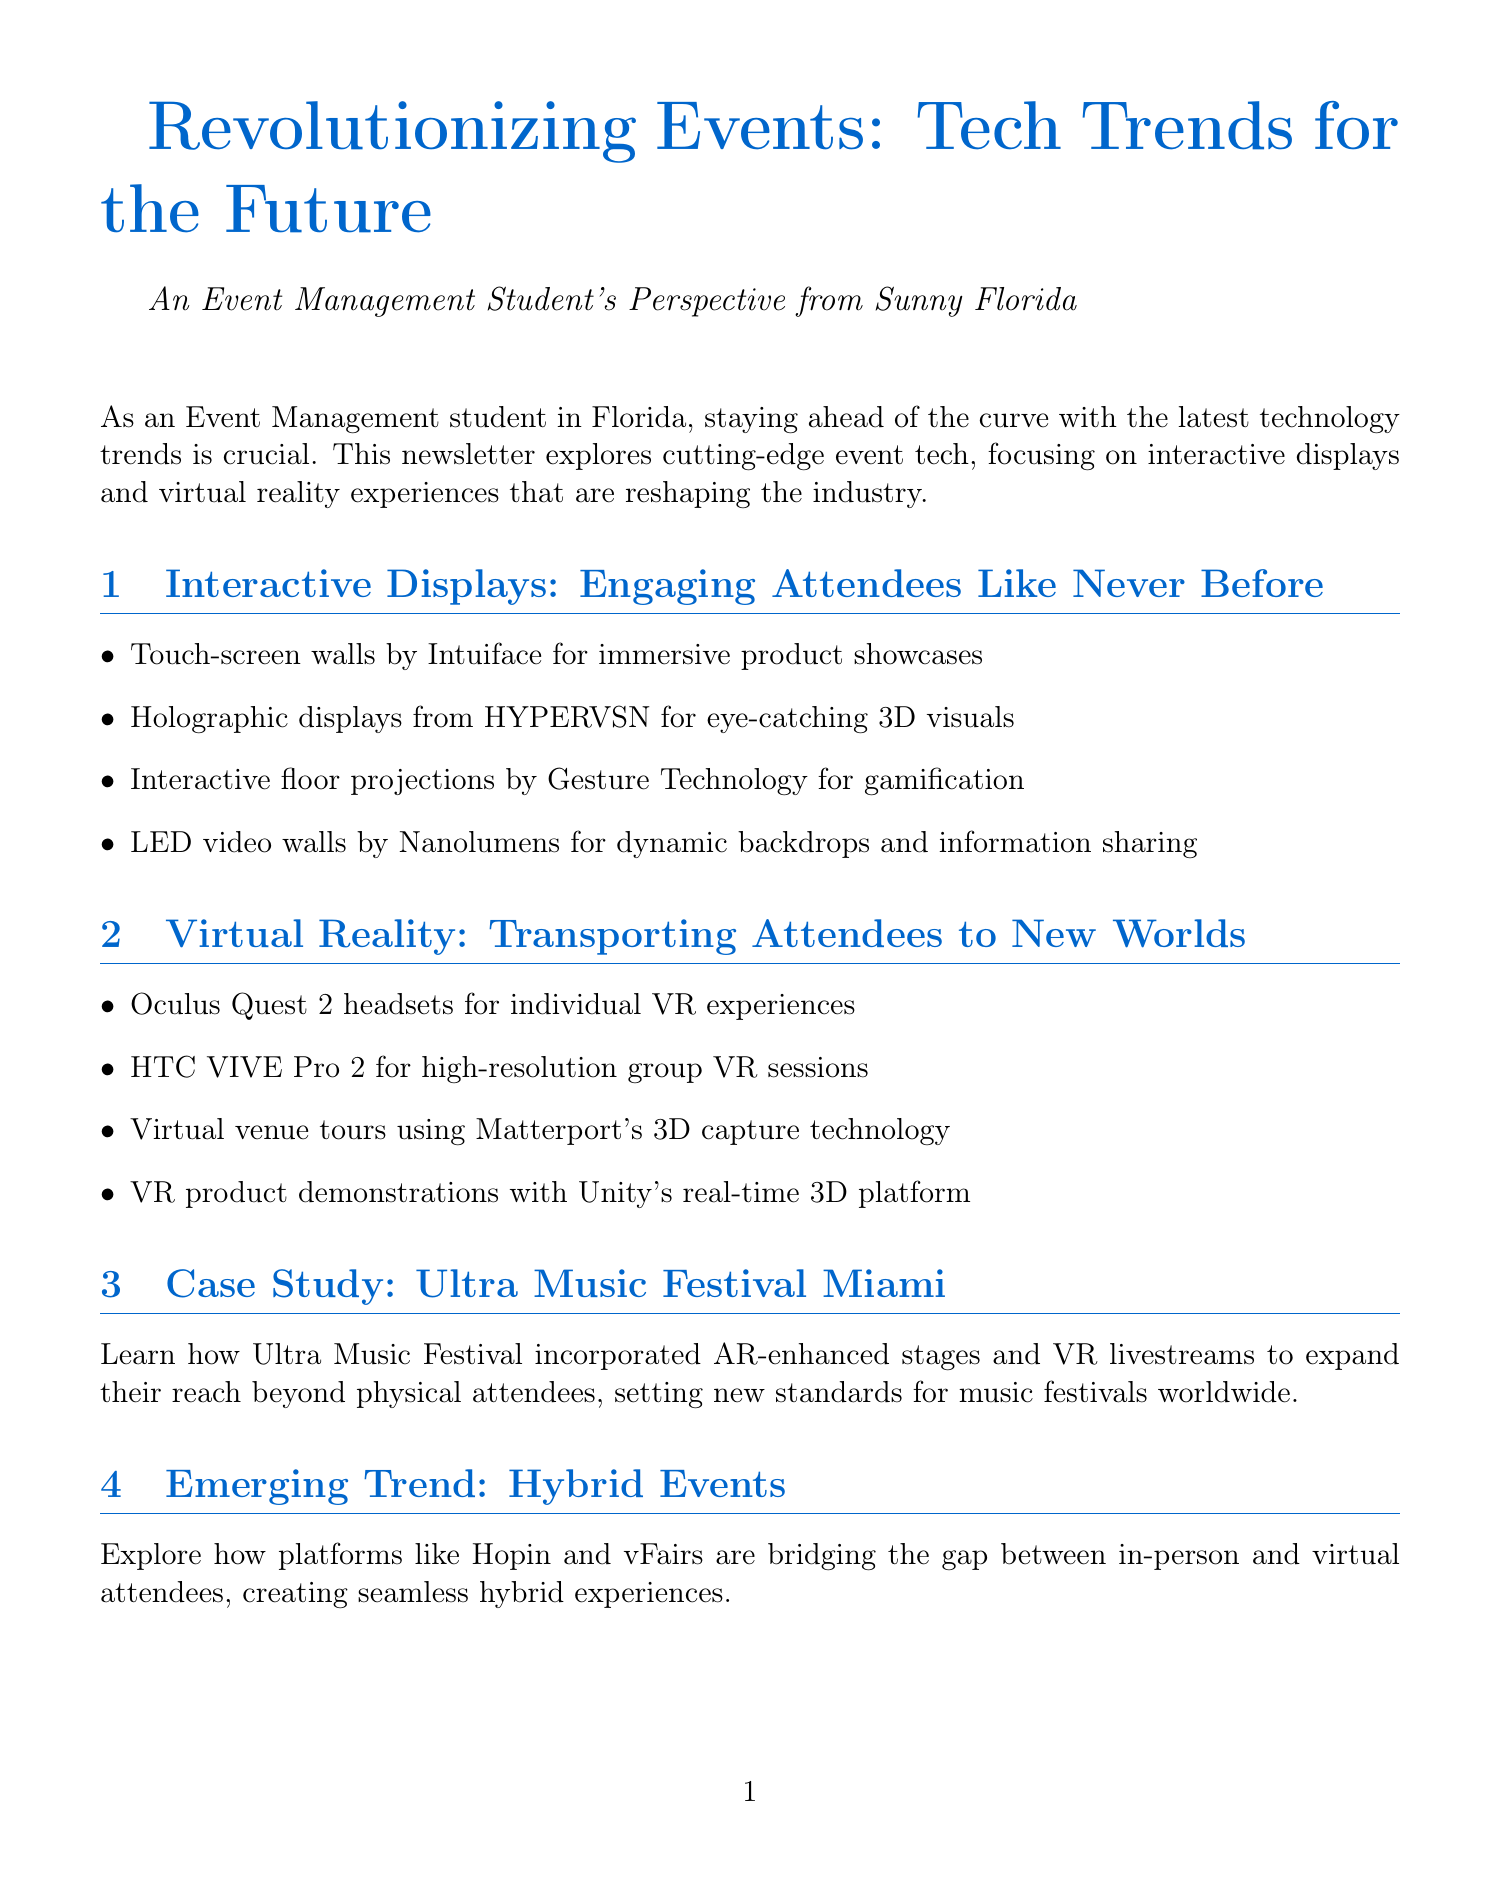What is the newsletter title? The title is prominently stated at the beginning of the document.
Answer: Revolutionizing Events: Tech Trends for the Future Who is interviewed in the newsletter? The document mentions an interview with a specific individual regarding event technology.
Answer: Sarah Johnson What technology is highlighted for immersive product showcases? The content lists various technologies, including one specifically for product showcases.
Answer: Touch-screen walls by Intuiface What event is used as a case study? The document includes a specific music festival as a case study for new technologies.
Answer: Ultra Music Festival Miami What is the name of the program that incorporates event technology? A program at a specific university is mentioned for providing hands-on experience with event tech.
Answer: Florida International University What type of displays are mentioned for gamification? The newsletter lists different technologies, including one specifically for gamification purposes.
Answer: Interactive floor projections by Gesture Technology What platform is mentioned for hybrid events? The content discusses platforms that facilitate hybrid events, specifying one of them.
Answer: Hopin What technology enables virtual venue tours? The document specifies a technology that allows for virtual tours of venues.
Answer: Matterport's 3D capture technology 